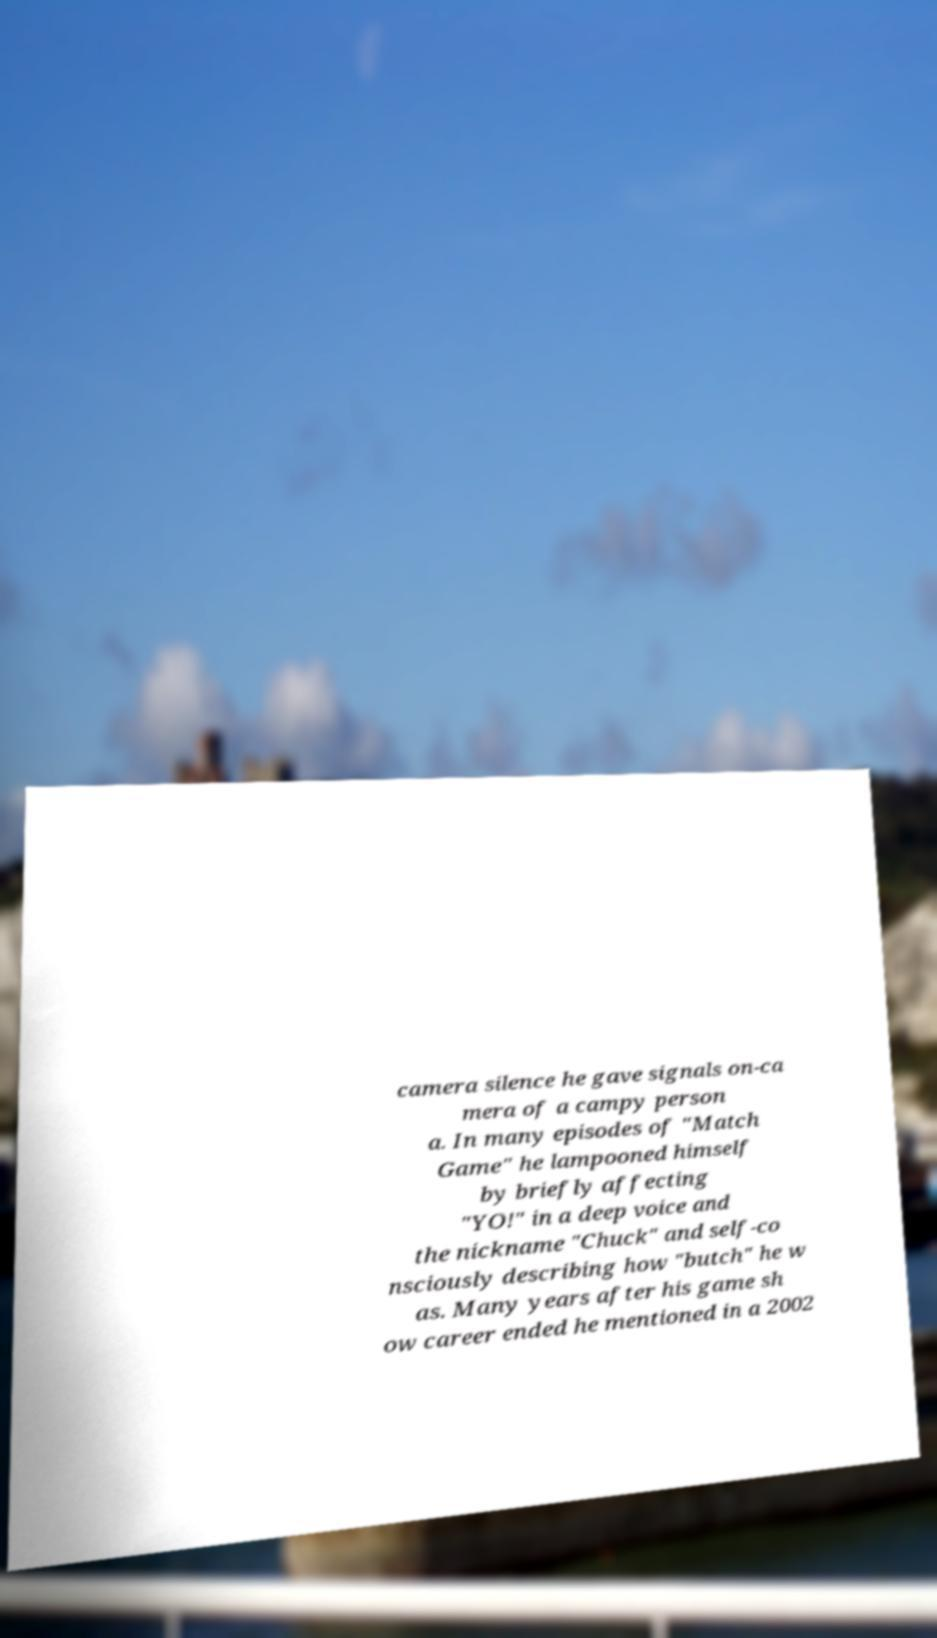What messages or text are displayed in this image? I need them in a readable, typed format. camera silence he gave signals on-ca mera of a campy person a. In many episodes of "Match Game" he lampooned himself by briefly affecting "YO!" in a deep voice and the nickname "Chuck" and self-co nsciously describing how "butch" he w as. Many years after his game sh ow career ended he mentioned in a 2002 